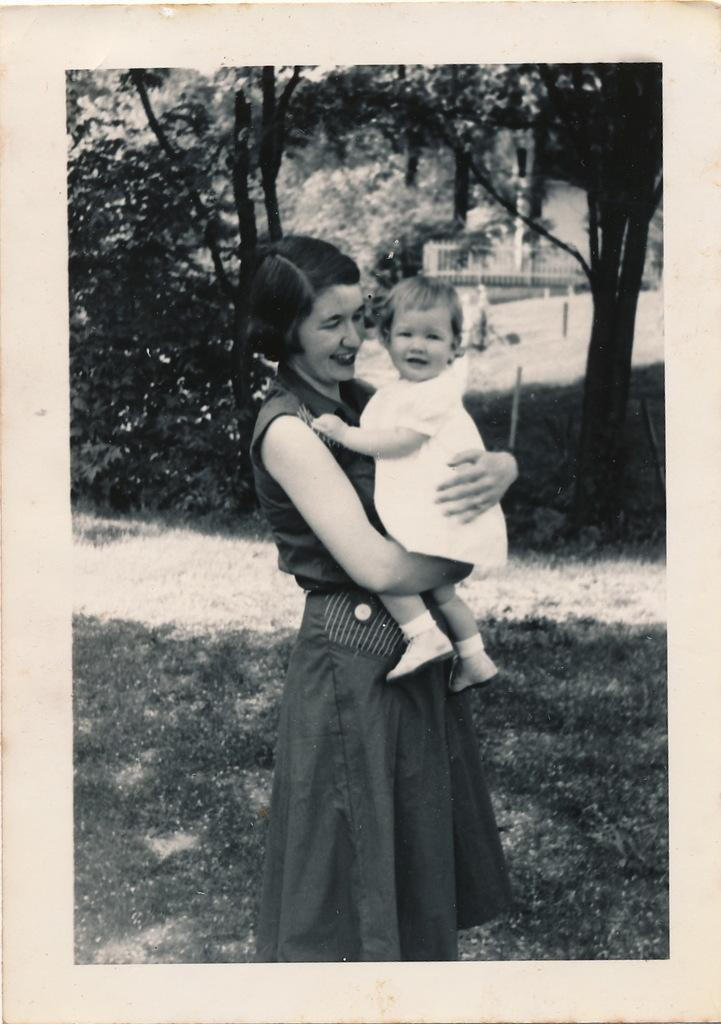What is the main subject of the photo in the image? The photo contains a woman standing and holding a baby. What is the woman doing in the photo? The woman is smiling in the photo. What type of environment is visible in the image? There is grass visible in the image, and trees are in the background. What type of writing can be seen on the baby's shirt in the image? There is no writing visible on the baby's shirt in the image. How many snails are crawling on the grass in the image? There are no snails present in the image; only grass and trees are visible in the background. 